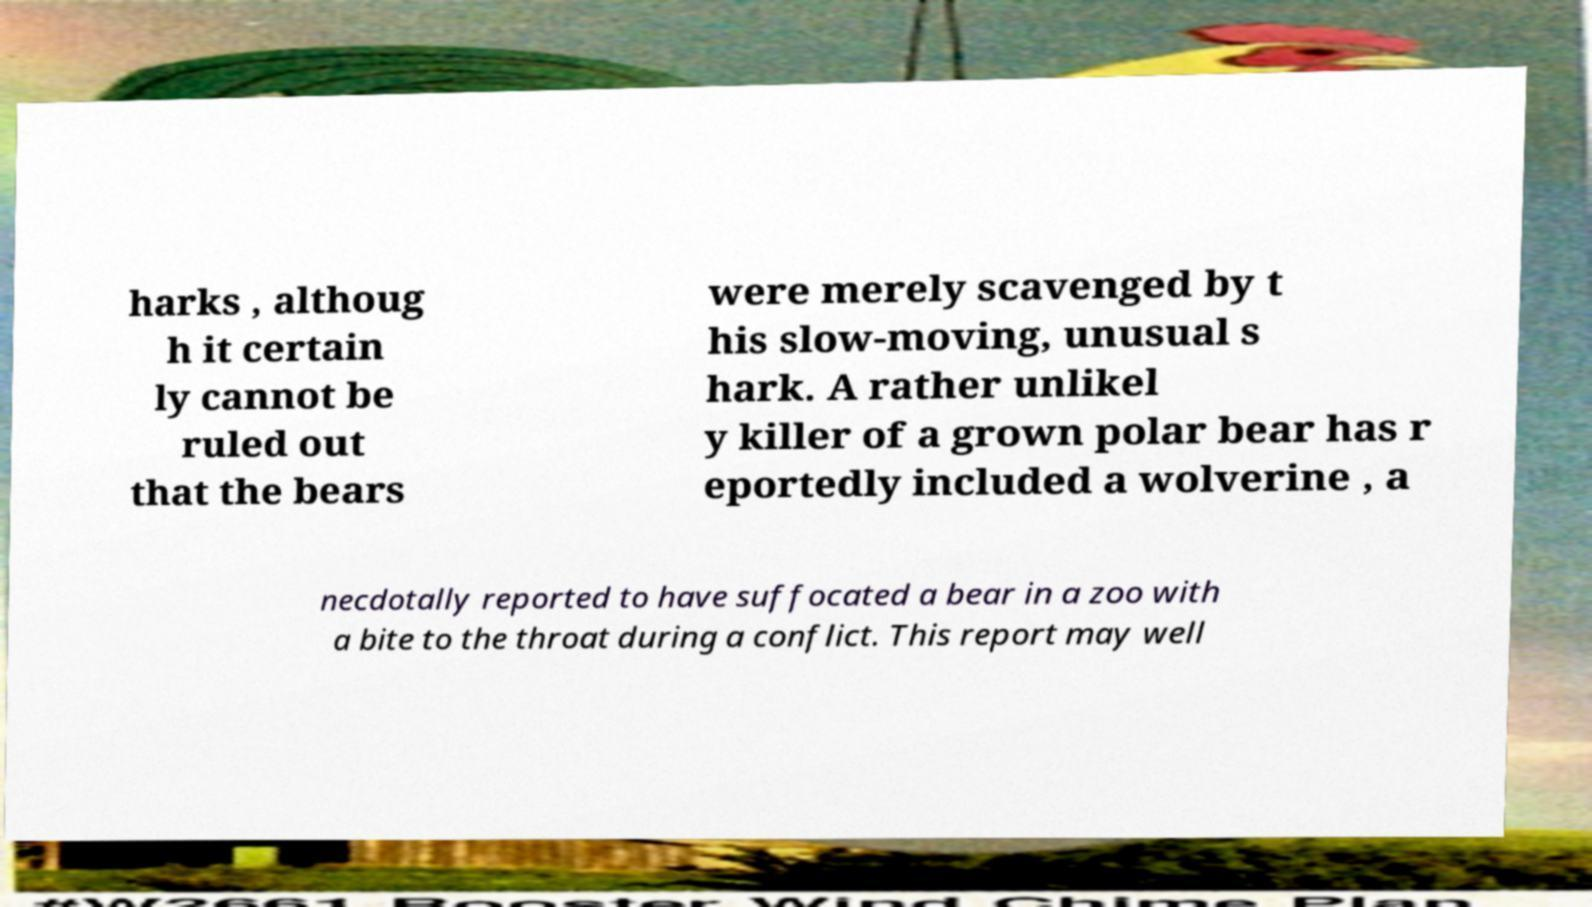Please identify and transcribe the text found in this image. harks , althoug h it certain ly cannot be ruled out that the bears were merely scavenged by t his slow-moving, unusual s hark. A rather unlikel y killer of a grown polar bear has r eportedly included a wolverine , a necdotally reported to have suffocated a bear in a zoo with a bite to the throat during a conflict. This report may well 